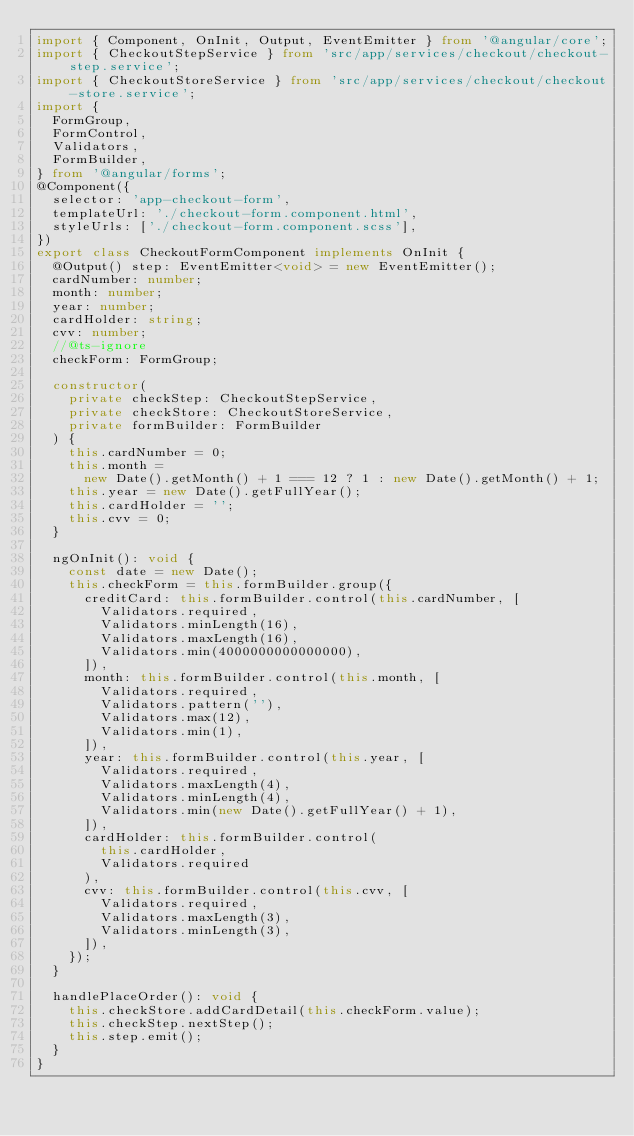<code> <loc_0><loc_0><loc_500><loc_500><_TypeScript_>import { Component, OnInit, Output, EventEmitter } from '@angular/core';
import { CheckoutStepService } from 'src/app/services/checkout/checkout-step.service';
import { CheckoutStoreService } from 'src/app/services/checkout/checkout-store.service';
import {
  FormGroup,
  FormControl,
  Validators,
  FormBuilder,
} from '@angular/forms';
@Component({
  selector: 'app-checkout-form',
  templateUrl: './checkout-form.component.html',
  styleUrls: ['./checkout-form.component.scss'],
})
export class CheckoutFormComponent implements OnInit {
  @Output() step: EventEmitter<void> = new EventEmitter();
  cardNumber: number;
  month: number;
  year: number;
  cardHolder: string;
  cvv: number;
  //@ts-ignore
  checkForm: FormGroup;

  constructor(
    private checkStep: CheckoutStepService,
    private checkStore: CheckoutStoreService,
    private formBuilder: FormBuilder
  ) {
    this.cardNumber = 0;
    this.month =
      new Date().getMonth() + 1 === 12 ? 1 : new Date().getMonth() + 1;
    this.year = new Date().getFullYear();
    this.cardHolder = '';
    this.cvv = 0;
  }

  ngOnInit(): void {
    const date = new Date();
    this.checkForm = this.formBuilder.group({
      creditCard: this.formBuilder.control(this.cardNumber, [
        Validators.required,
        Validators.minLength(16),
        Validators.maxLength(16),
        Validators.min(4000000000000000),
      ]),
      month: this.formBuilder.control(this.month, [
        Validators.required,
        Validators.pattern(''),
        Validators.max(12),
        Validators.min(1),
      ]),
      year: this.formBuilder.control(this.year, [
        Validators.required,
        Validators.maxLength(4),
        Validators.minLength(4),
        Validators.min(new Date().getFullYear() + 1),
      ]),
      cardHolder: this.formBuilder.control(
        this.cardHolder,
        Validators.required
      ),
      cvv: this.formBuilder.control(this.cvv, [
        Validators.required,
        Validators.maxLength(3),
        Validators.minLength(3),
      ]),
    });
  }

  handlePlaceOrder(): void {
    this.checkStore.addCardDetail(this.checkForm.value);
    this.checkStep.nextStep();
    this.step.emit();
  }
}
</code> 